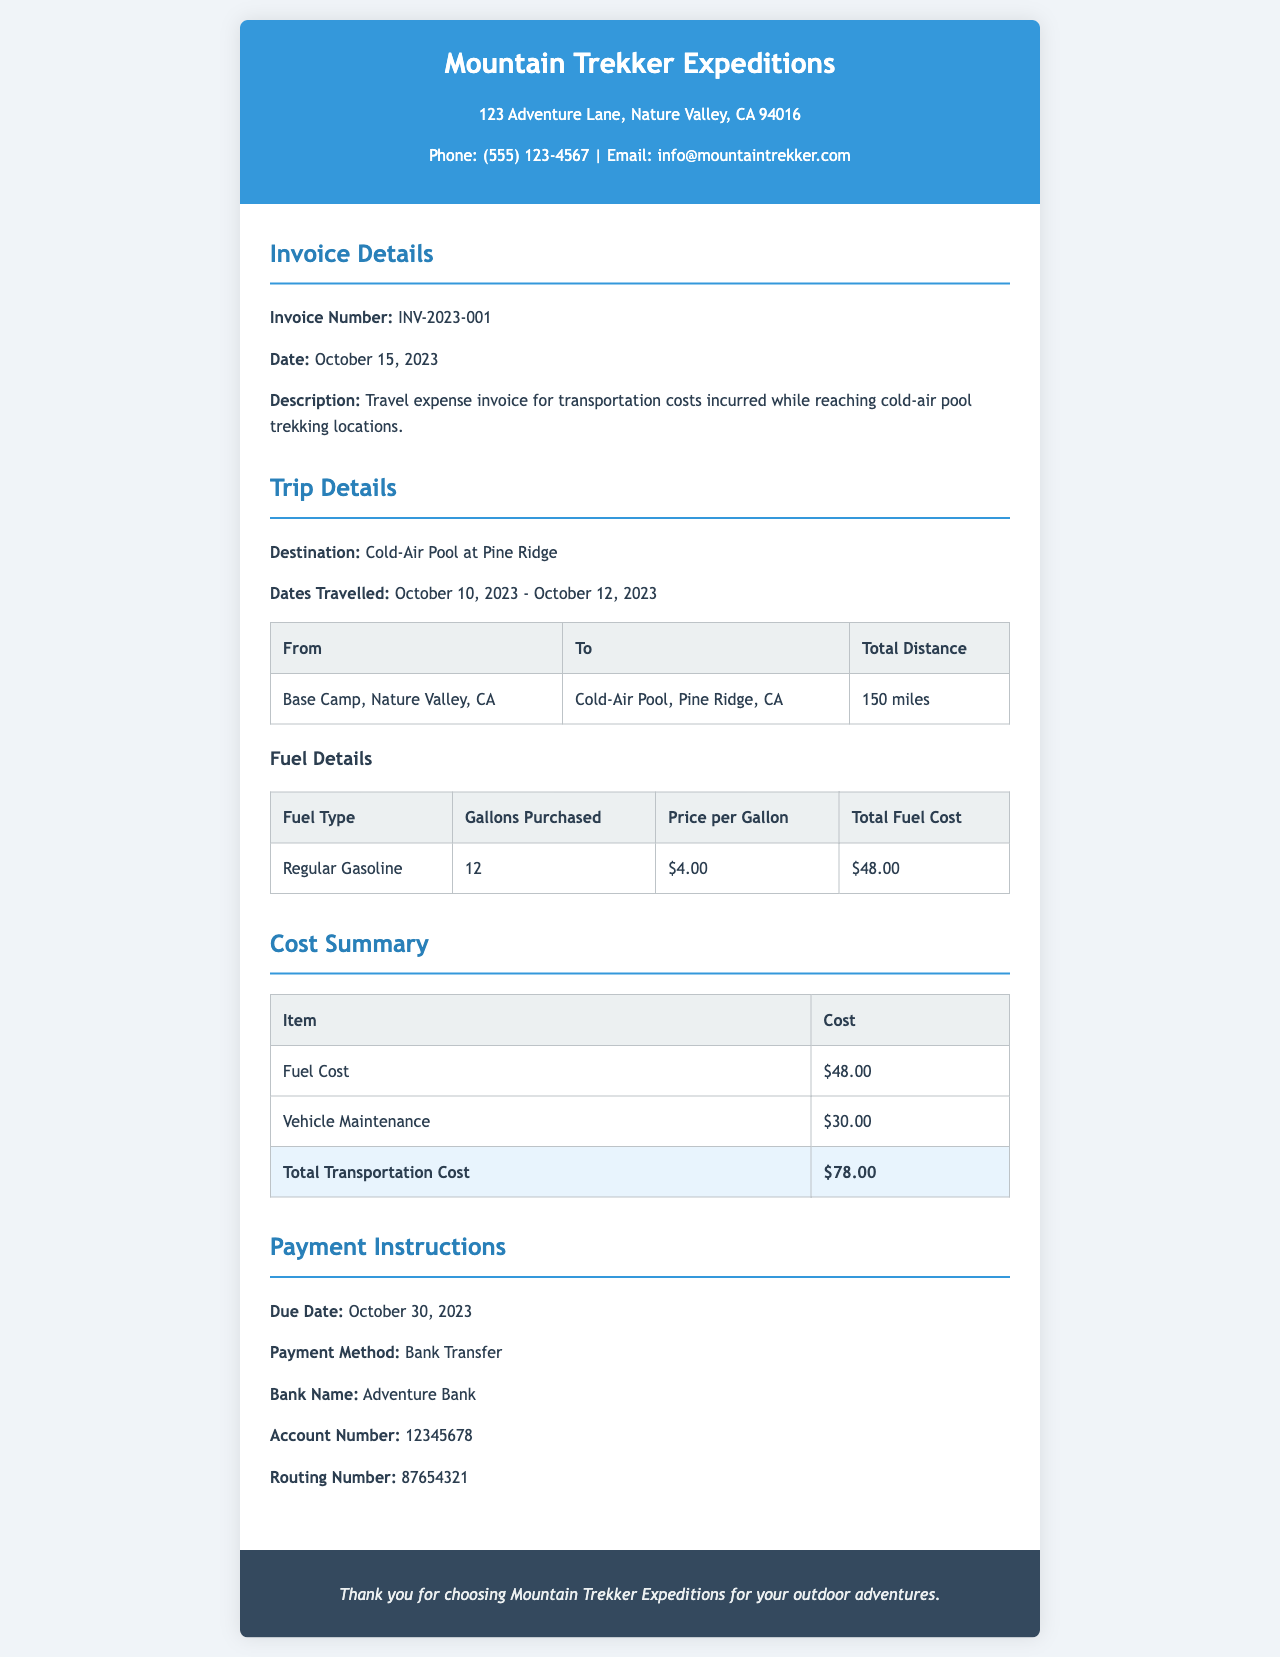What is the invoice number? The invoice number is explicitly mentioned in the document as INV-2023-001.
Answer: INV-2023-001 What is the due date for payment? The document specifies the due date for payment as October 30, 2023.
Answer: October 30, 2023 How much was charged for vehicle maintenance? The cost for vehicle maintenance is listed in the cost summary section of the invoice as $30.00.
Answer: $30.00 What is the total distance traveled to the cold-air pool? The total distance traveled is mentioned in the trip details table as 150 miles.
Answer: 150 miles What was the price per gallon of fuel? The price per gallon of fuel is noted in the fuel details section as $4.00.
Answer: $4.00 What is the total transportation cost? The total transportation cost is calculated in the cost summary section as $78.00.
Answer: $78.00 What type of fuel was purchased? The type of fuel is detailed in the fuel details table, which states Regular Gasoline.
Answer: Regular Gasoline Which bank should the payment be transferred to? The invoice specifies Adventure Bank as the bank for the payment.
Answer: Adventure Bank What were the dates travelled for the trip? The dates travelled are provided in the trip details as October 10, 2023 - October 12, 2023.
Answer: October 10, 2023 - October 12, 2023 